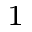<formula> <loc_0><loc_0><loc_500><loc_500>^ { 1 }</formula> 